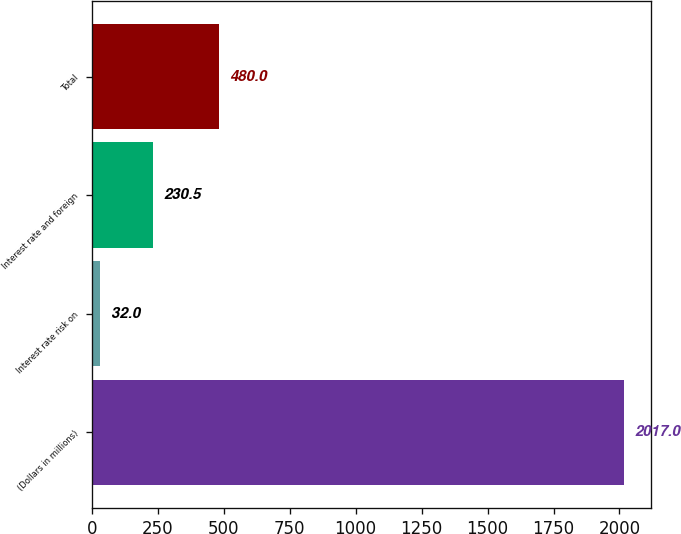Convert chart. <chart><loc_0><loc_0><loc_500><loc_500><bar_chart><fcel>(Dollars in millions)<fcel>Interest rate risk on<fcel>Interest rate and foreign<fcel>Total<nl><fcel>2017<fcel>32<fcel>230.5<fcel>480<nl></chart> 